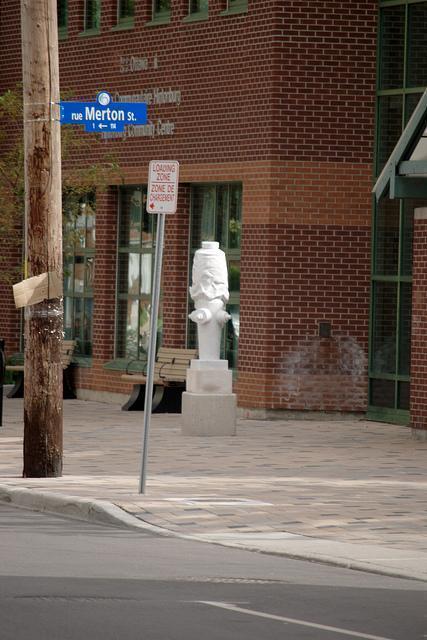The sculpture in front of the building is modeled after what common object found on a sidewalk?
Answer the question by selecting the correct answer among the 4 following choices.
Options: Fire hydrant, newspaper box, parking meter, garbage can. Fire hydrant. 